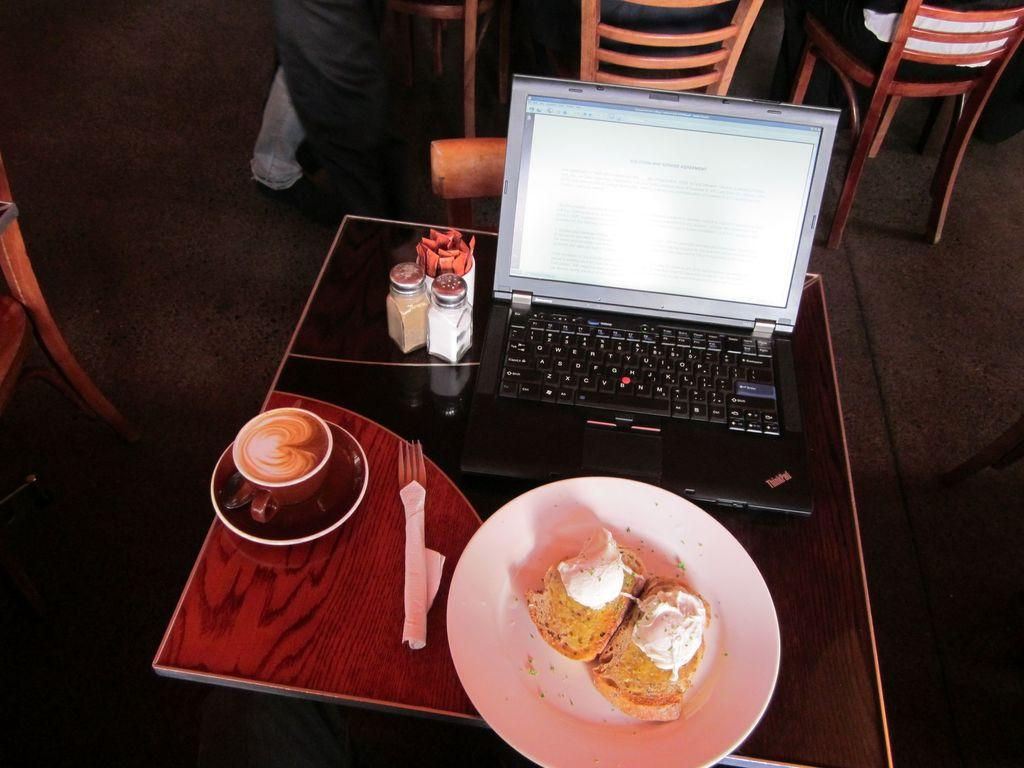What part of a person can be seen in the image? There is a person's leg in the image. What type of furniture is present in the image? There are chairs and a table in the image. What is on the table in the image? A system, a plate, a fork, a tea cup, and food are present on the table in the image. What type of scarecrow is present in the image? There is no scarecrow present in the image. What thoughts are going through the person's mind in the image? We cannot determine the person's thoughts from the image. What type of glass is on the table in the image? There is no glass present on the table in the image. 